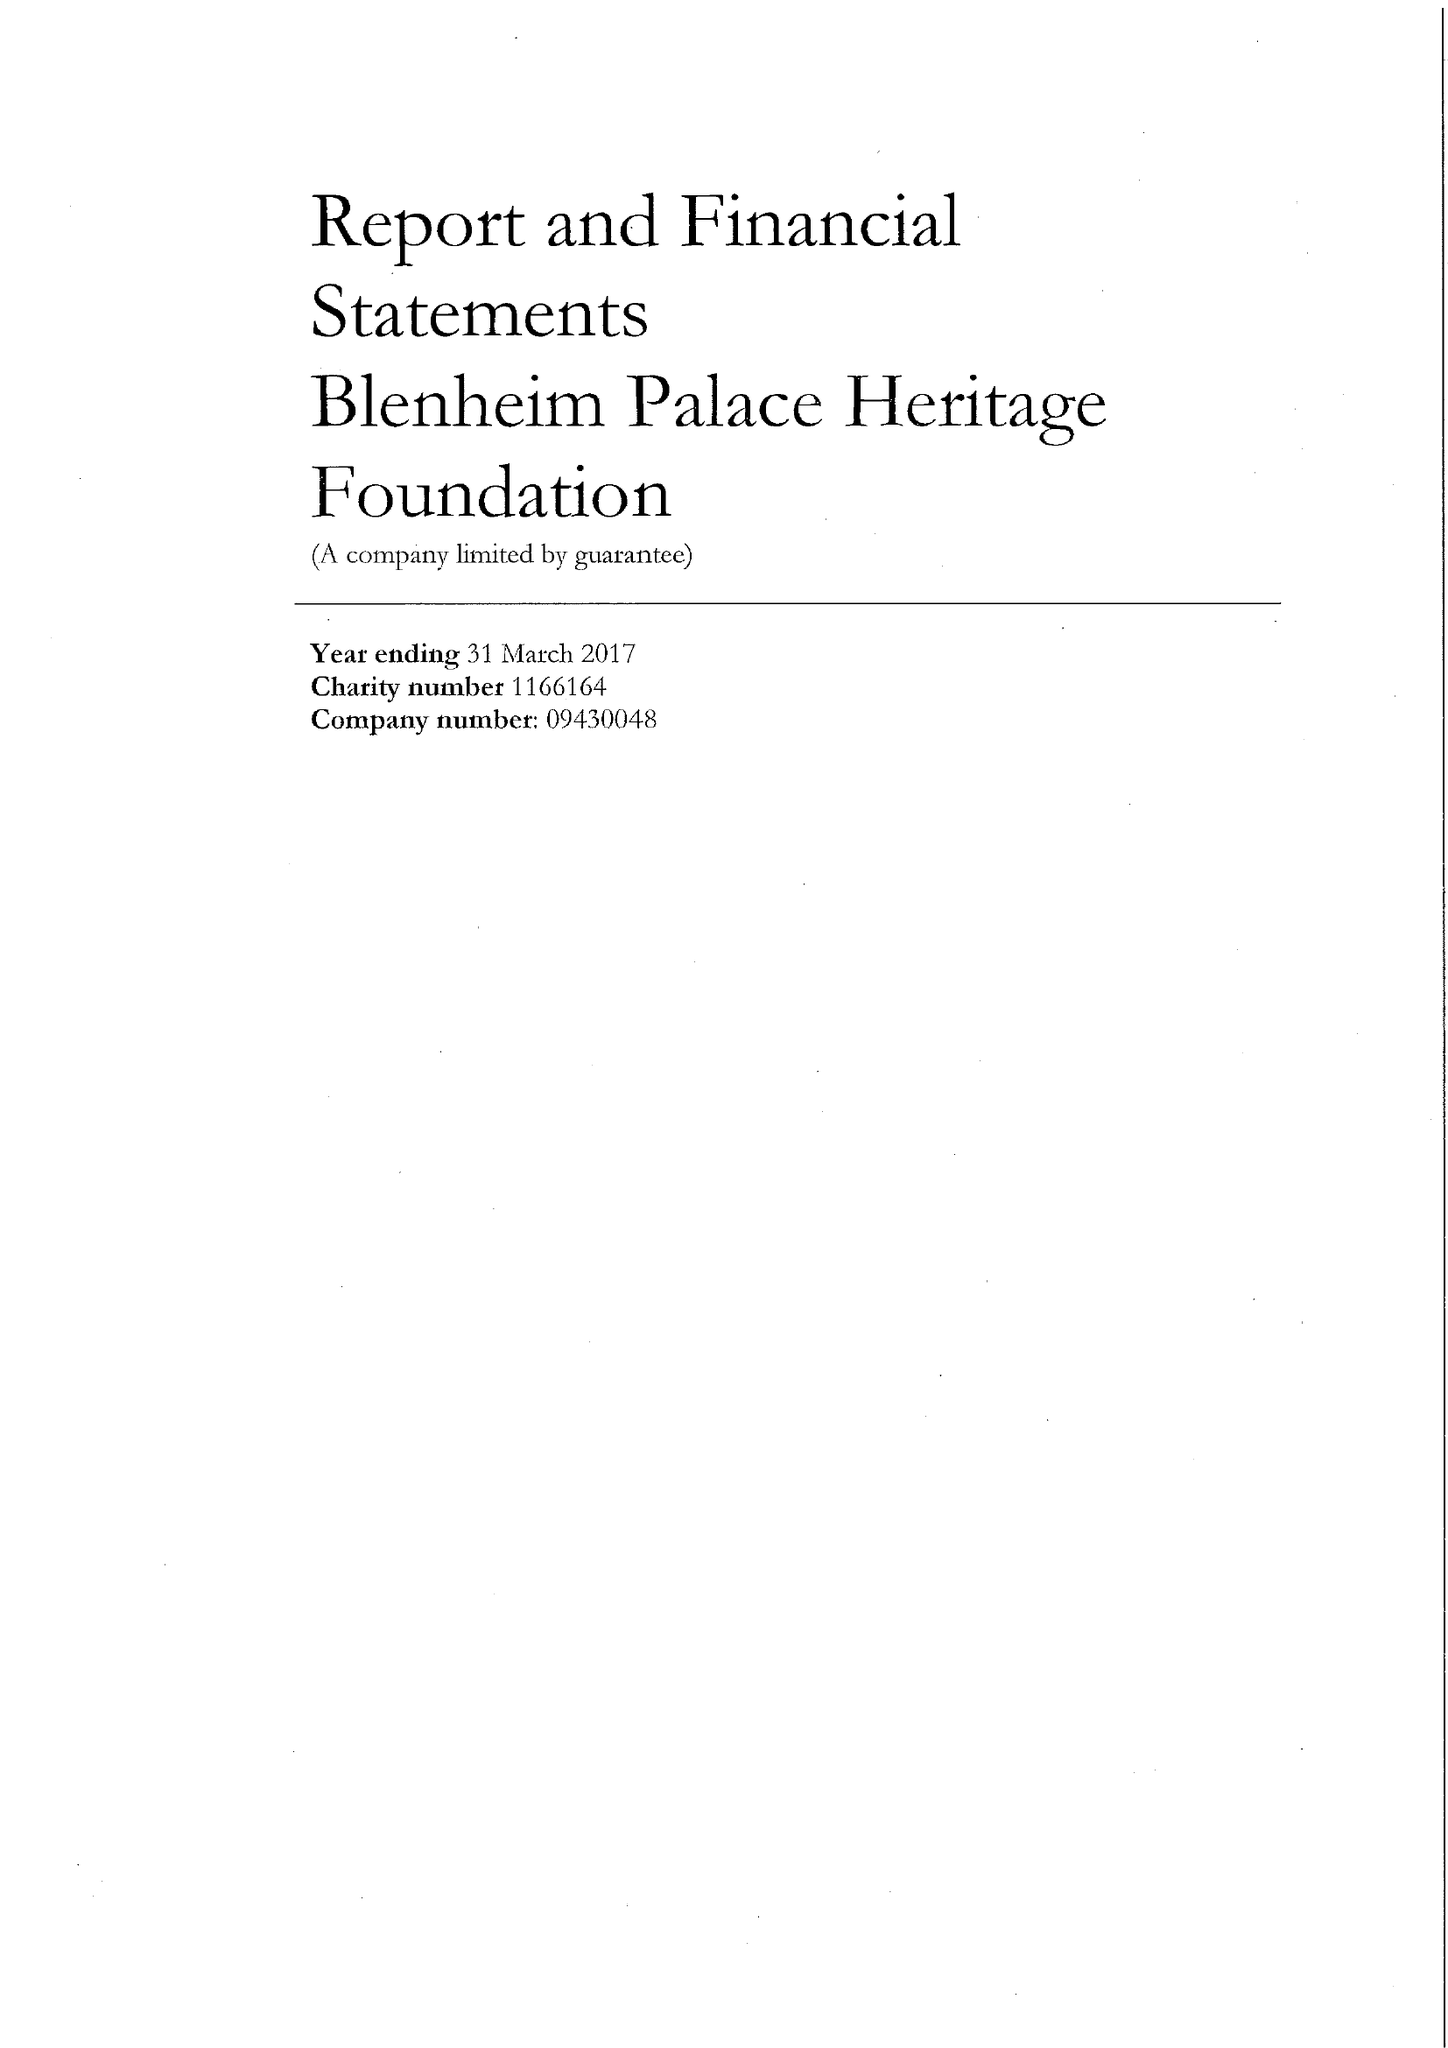What is the value for the income_annually_in_british_pounds?
Answer the question using a single word or phrase. 8535684.00 